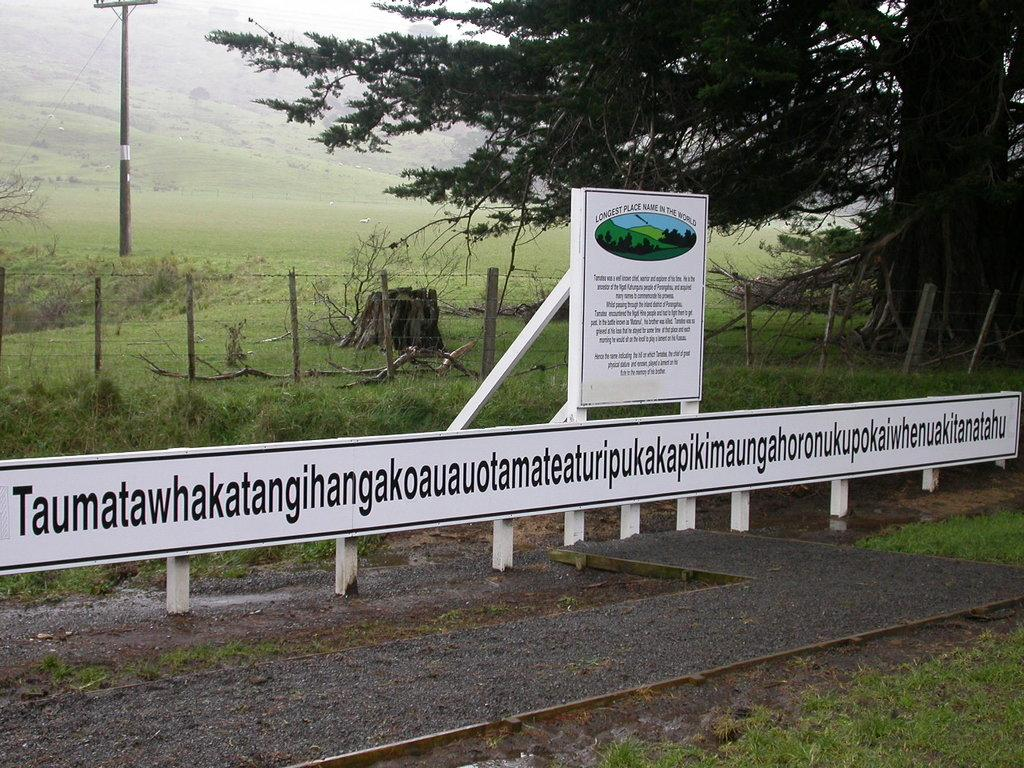What type of signage is present in the image? There are hoardings in the image. What is written or displayed on the hoardings? There is text on the hoardings. What can be seen in the background of the image? There are trees, grass, and a pole in the background of the image. What date is circled on the calendar in the image? There is no calendar present in the image. 